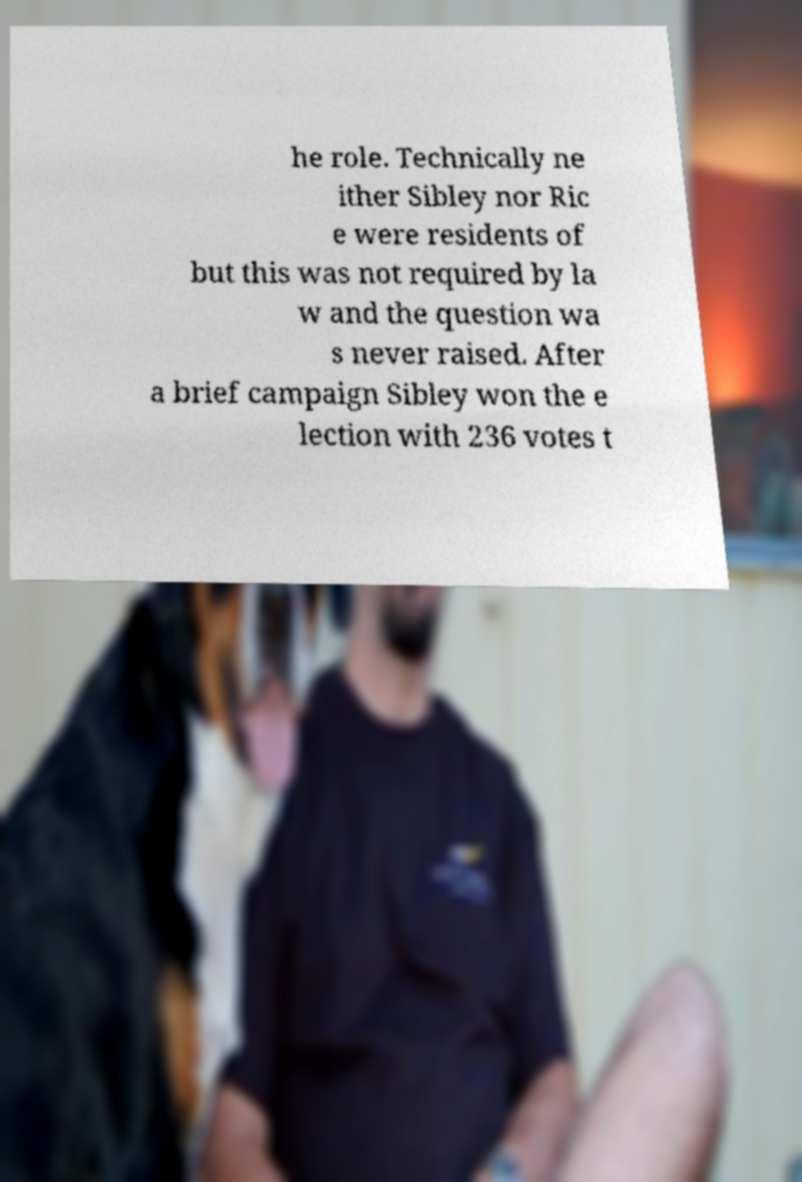Please read and relay the text visible in this image. What does it say? he role. Technically ne ither Sibley nor Ric e were residents of but this was not required by la w and the question wa s never raised. After a brief campaign Sibley won the e lection with 236 votes t 